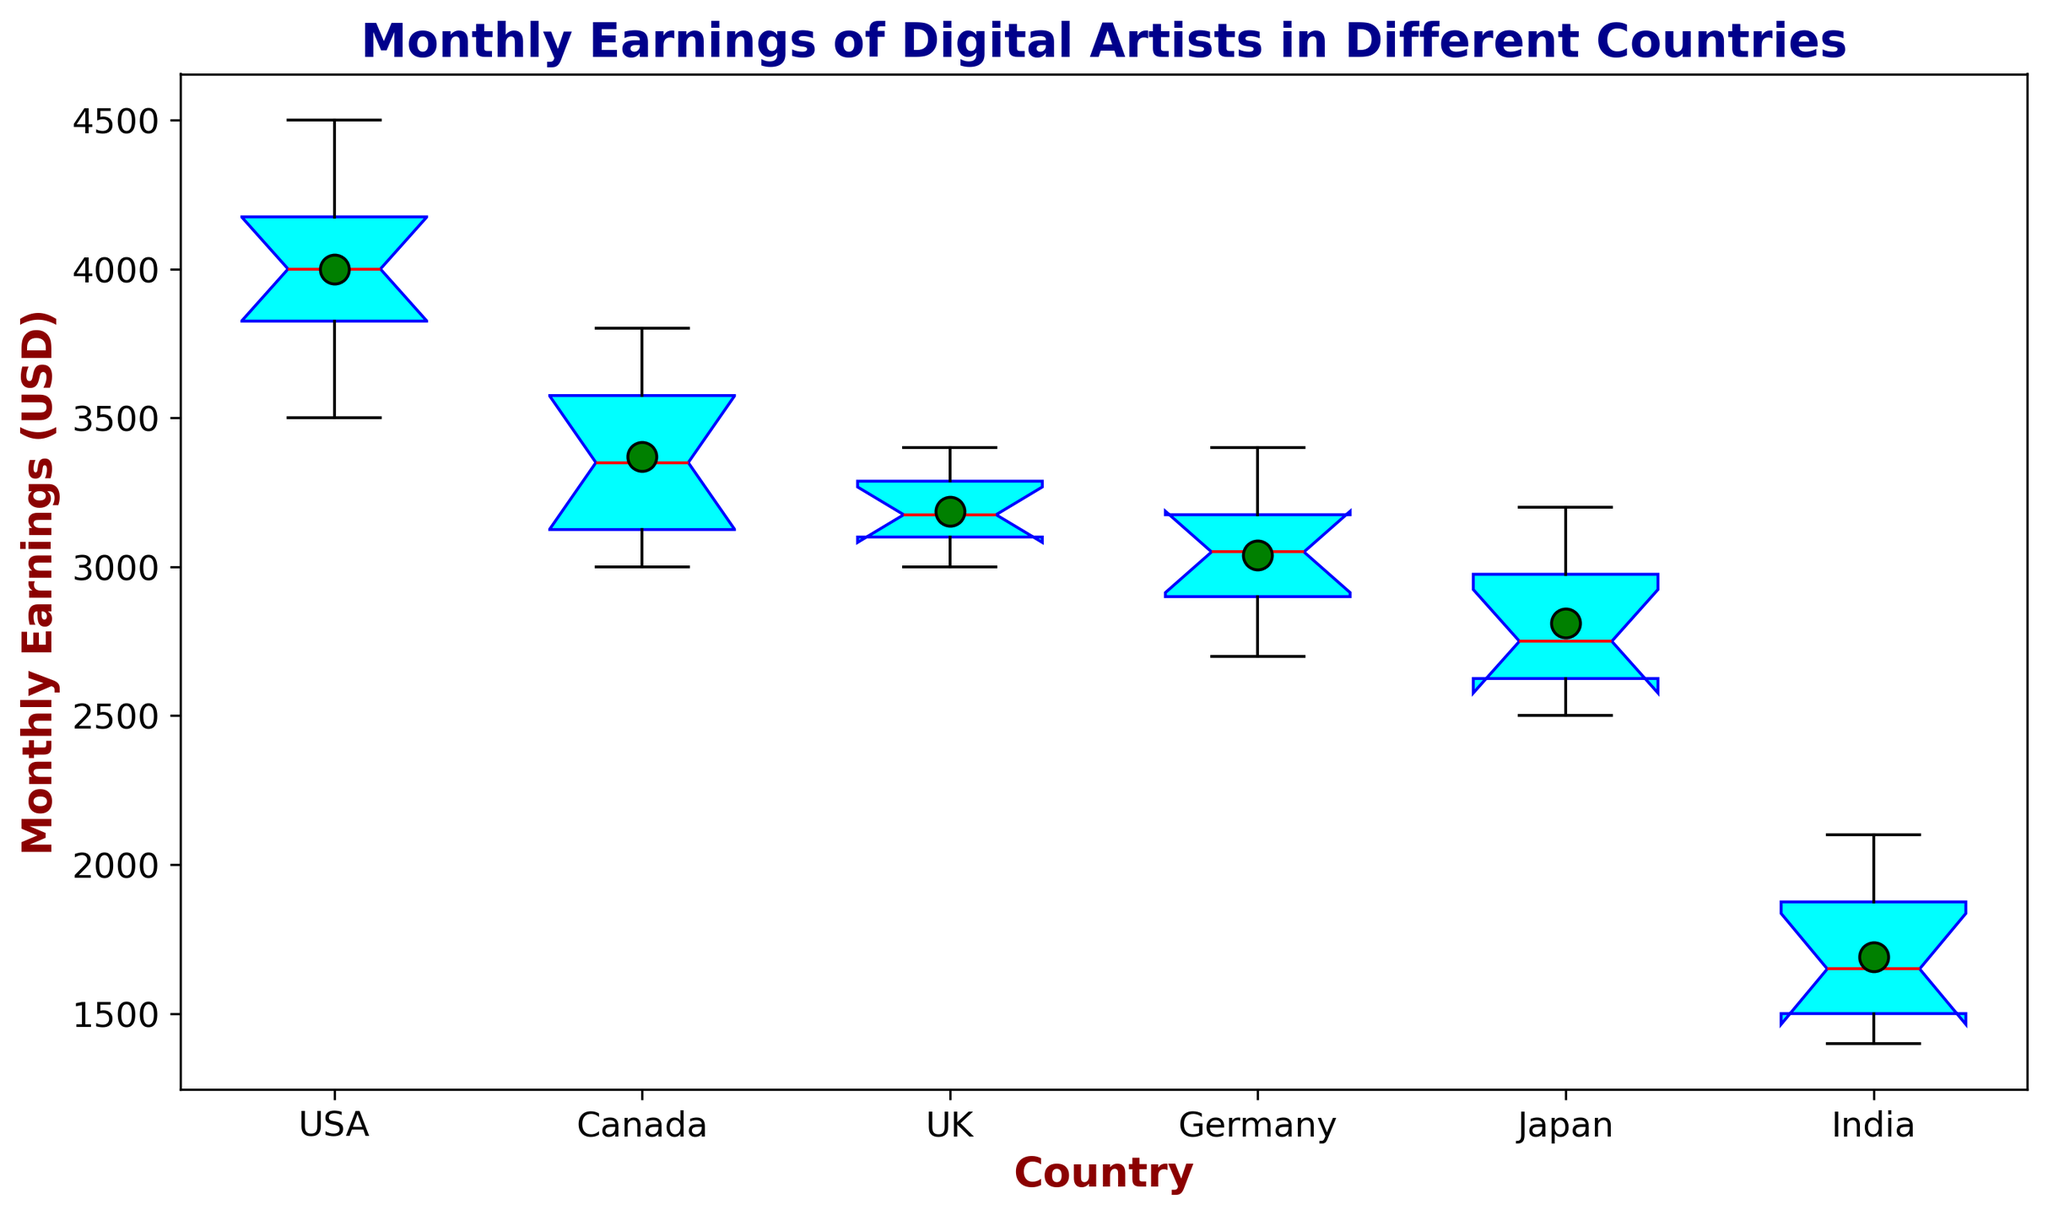Which country has the highest median monthly earnings of digital artists? To find the highest median, look at the line inside each box. The USA has the highest median monthly earnings as the red line is positioned higher than all other countries.
Answer: USA Which country shows the greatest range in monthly earnings of digital artists? The range can be assessed by looking at the length of the boxes and the whiskers. The USA's whiskers are the longest, indicating the greatest range.
Answer: USA What's the difference in median monthly earnings between digital artists in the USA and Canada? The median monthly earnings of the USA is approximately $4000, and for Canada, it's around $3300. The difference is $4000 - $3300 = $700.
Answer: $700 What's the range of monthly earnings for digital artists in India? The range is the difference between the maximum and minimum data points. For India, it ranges from $1400 to $2100, so the range is $2100 - $1400 = $700.
Answer: $700 Which country has the smallest interquartile range (IQR) in monthly earnings of digital artists? The IQR is the length of the box itself. Japan has the smallest box, indicating the smallest IQR.
Answer: Japan How does the mean monthly earnings compare between the USA and Japan? The mean is represented by green circles. The mean for the USA is higher and positioned far above that of Japan's.
Answer: USA’s mean is higher Which country's digital artists have the most consistent monthly earnings based on the box plot? Consistency can be inferred from the variability shown in the box plot. Japan has the smallest spread with the shortest box and whiskers, indicating the most consistent earnings.
Answer: Japan Are there any potential outliers in the UK, and if so, what are they likely to be? Outliers appear as individual points outside the whiskers of the box plot. There don't appear to be any points plotted outside the whiskers for the UK, so there are likely no outliers.
Answer: No How does the box height (the IQR) for Canada compare with that for Germany? The IQR for Canada is the height of the box itself. Germany’s box is taller than Canada’s, indicating a larger IQR.
Answer: Germany’s IQR is larger 